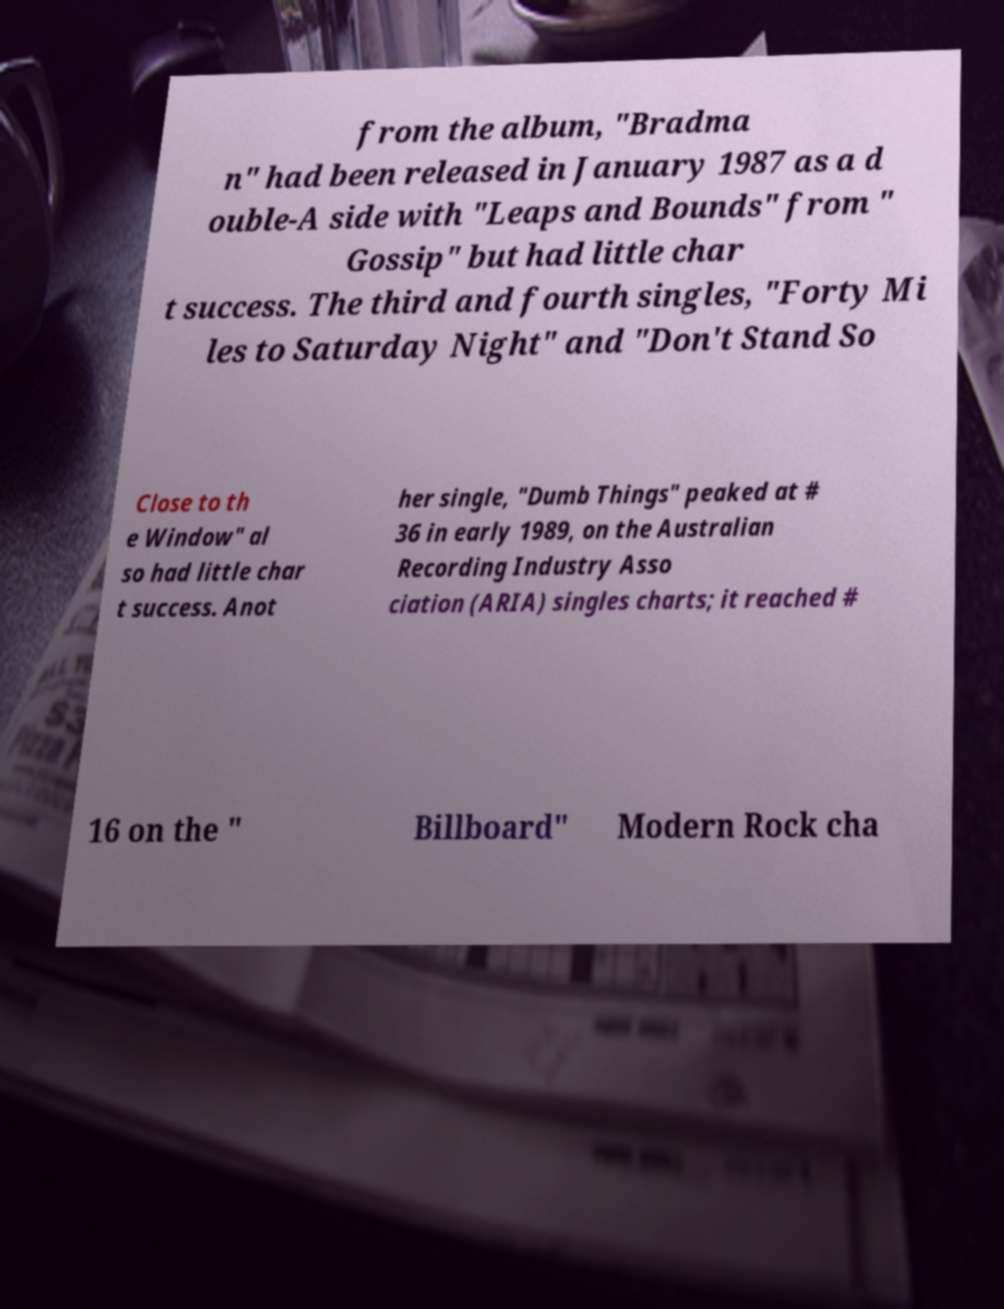Could you extract and type out the text from this image? from the album, "Bradma n" had been released in January 1987 as a d ouble-A side with "Leaps and Bounds" from " Gossip" but had little char t success. The third and fourth singles, "Forty Mi les to Saturday Night" and "Don't Stand So Close to th e Window" al so had little char t success. Anot her single, "Dumb Things" peaked at # 36 in early 1989, on the Australian Recording Industry Asso ciation (ARIA) singles charts; it reached # 16 on the " Billboard" Modern Rock cha 